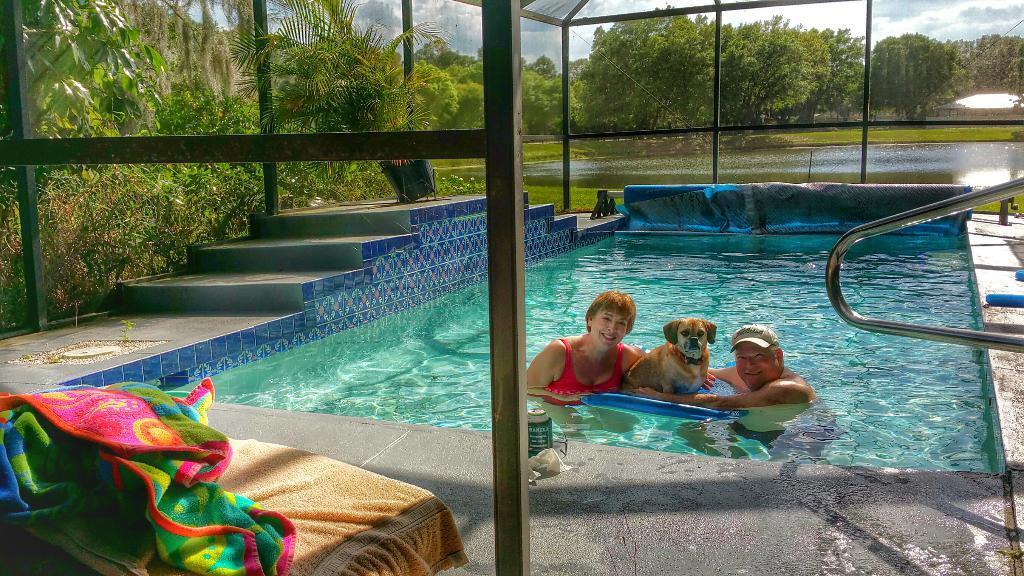Please provide a concise description of this image. In this image I can see a two persons and dog in a pool. There are stairs and towel. At the back side there are trees. 